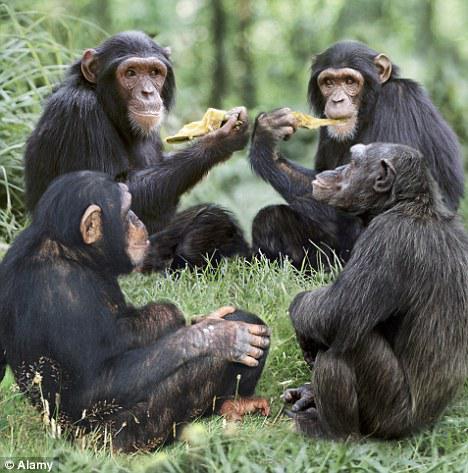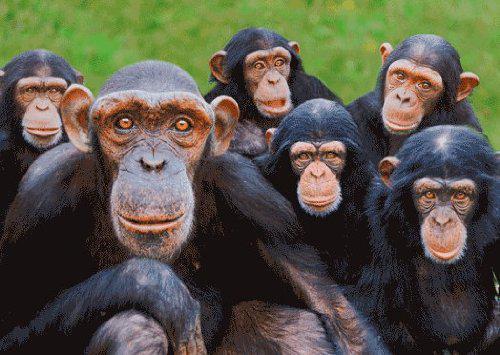The first image is the image on the left, the second image is the image on the right. Evaluate the accuracy of this statement regarding the images: "An image shows a trio of chimps in a row up off the ground on something branch-like.". Is it true? Answer yes or no. No. The first image is the image on the left, the second image is the image on the right. Analyze the images presented: Is the assertion "Some apes are holding food in their hands." valid? Answer yes or no. Yes. 